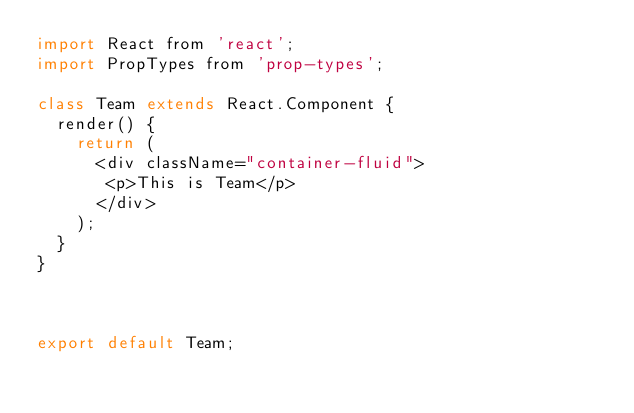<code> <loc_0><loc_0><loc_500><loc_500><_JavaScript_>import React from 'react';
import PropTypes from 'prop-types';

class Team extends React.Component {
  render() {
    return (
      <div className="container-fluid">
       <p>This is Team</p>
      </div>
    );
  }
}



export default Team;


</code> 